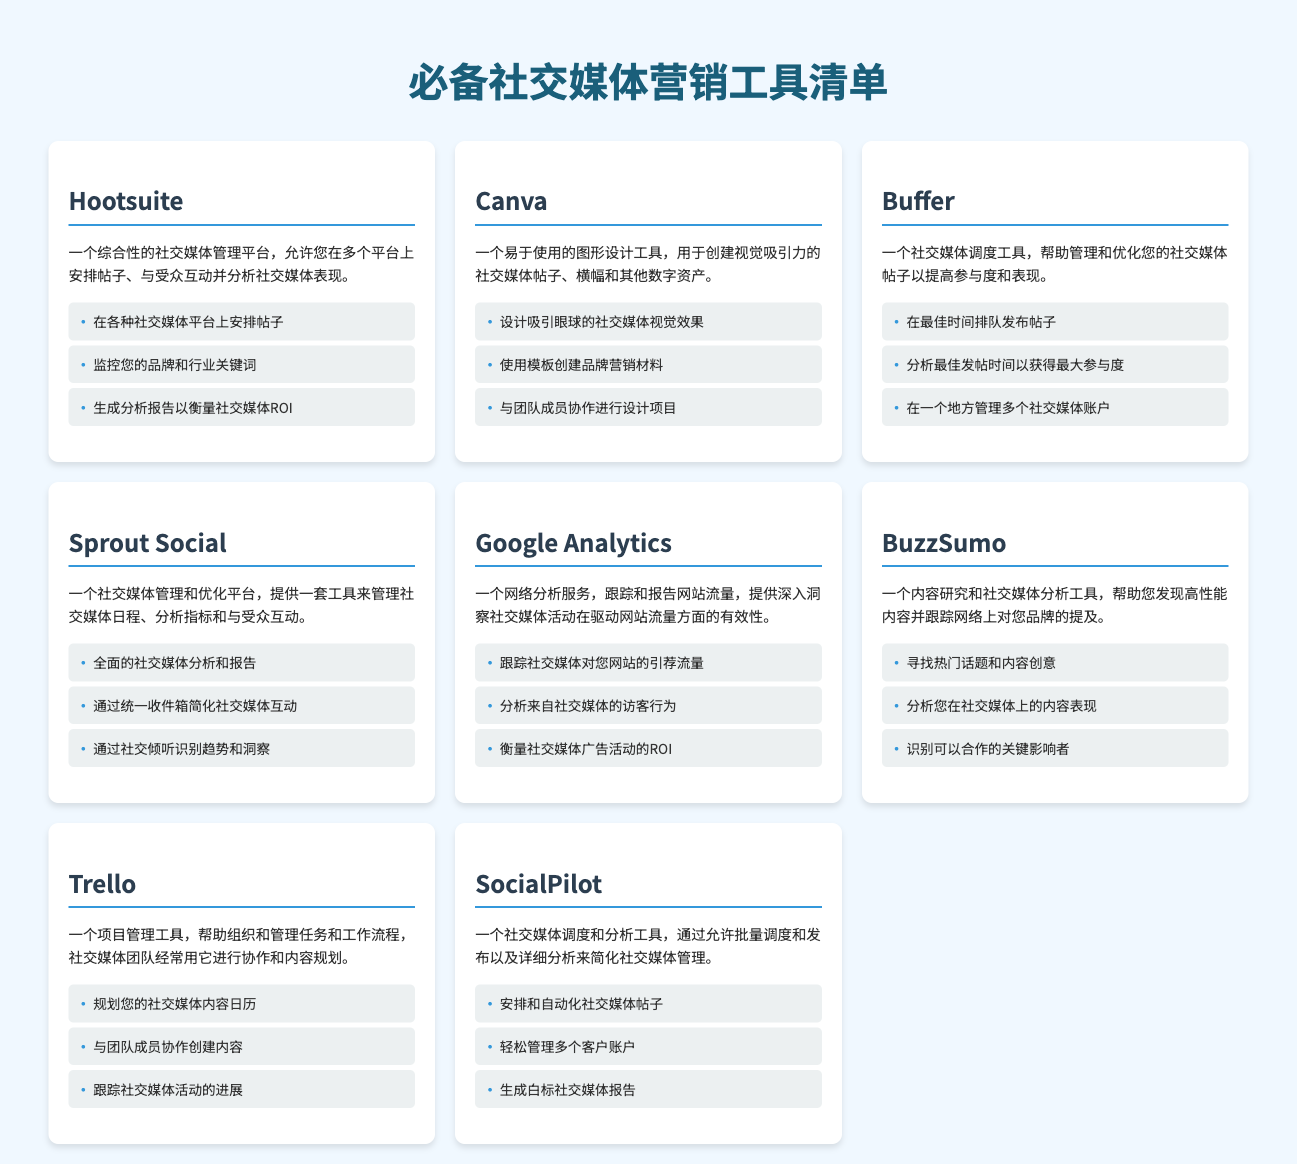什么工具可以安排社交媒体帖子？ 根据文档，Hootsuite 是一个可以安排社交媒体帖子的工具。
Answer: Hootsuite Canva 的主要功能是什么？ 根据文档，Canva 是一个易于使用的图形设计工具，用于创建视觉吸引力的社交媒体帖子。
Answer: 图形设计 Buffer 的用途是什么？ Buffer 是一个社交媒体调度工具，帮助管理和优化社交媒体帖子。
Answer: 社交媒体调度 使用 Google Analytics 可以追踪什么？ Google Analytics 可以跟踪社交媒体对网站的引荐流量。
Answer: 引荐流量 哪种工具用于项目管理和内容规划？ Trello 是一个项目管理工具，用于组织和管理任务和工作流程。
Answer: Trello 哪个工具可以生成分析报告？ Hootsuite 可以生成分析报告以衡量社交媒体 ROI。
Answer: Hootsuite BuzzSumo 的主要功能是什么？ BuzzSumo 是一个内容研究和社交媒体分析工具，帮助您发现高性能内容。
Answer: 内容研究 使用 SocialPilot 最主要的功能是什么？ SocialPilot 是一个社交媒体调度和分析工具，允许批量调度和发布。
Answer: 批量调度 